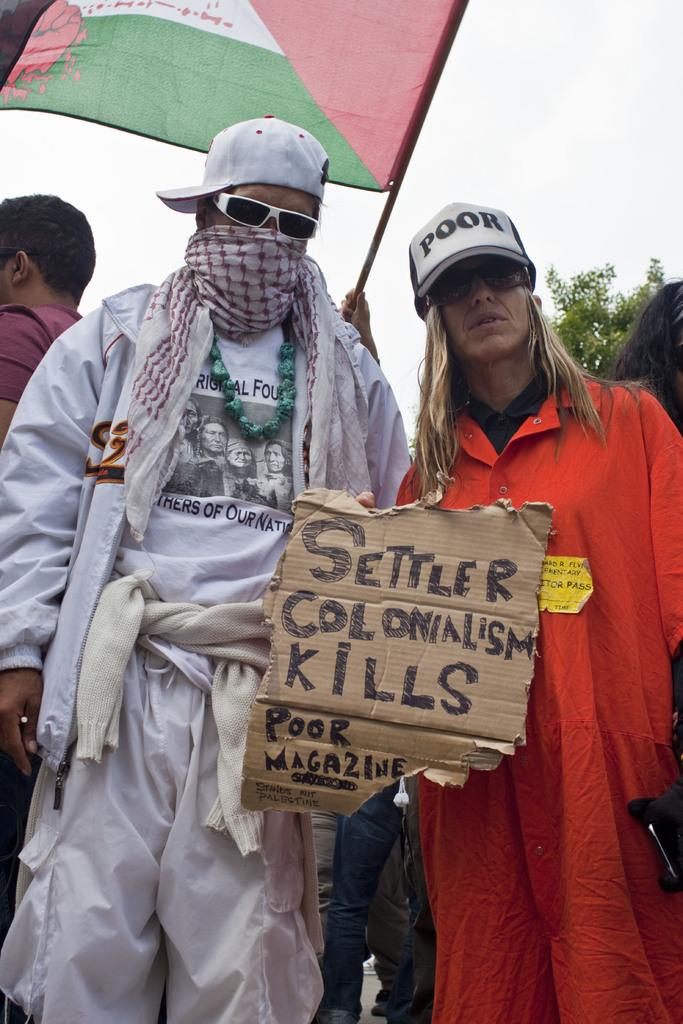What are the people in the foreground of the image doing? The people in the foreground of the image are holding a poster. What can be seen in the background of the image? There are people, a tree, a flag, and the sky visible in the background of the image. How many elements can be identified in the background of the image? There are four elements in the background of the image: people, a tree, a flag, and the sky. What type of wren is perched on the flag in the image? There is no wren present in the image; it only features a flag in the background. How many dolls are sitting on the tree in the image? There are no dolls present in the image; it only features a tree in the background. 